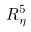<formula> <loc_0><loc_0><loc_500><loc_500>R _ { \eta } ^ { 5 }</formula> 